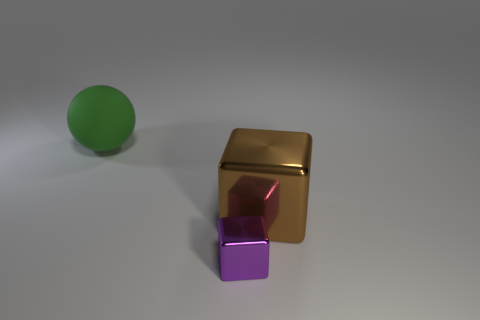Add 3 brown things. How many objects exist? 6 Subtract all balls. How many objects are left? 2 Subtract all blue rubber things. Subtract all small shiny objects. How many objects are left? 2 Add 1 tiny purple shiny objects. How many tiny purple shiny objects are left? 2 Add 3 small yellow metal objects. How many small yellow metal objects exist? 3 Subtract 0 cyan spheres. How many objects are left? 3 